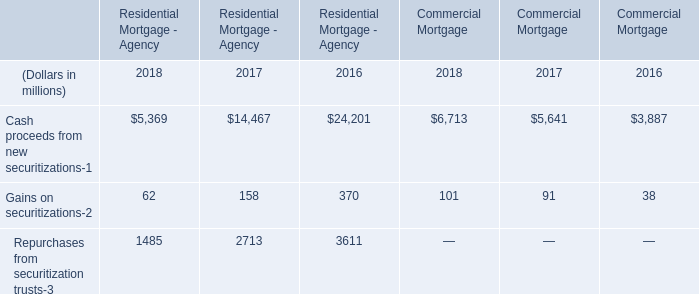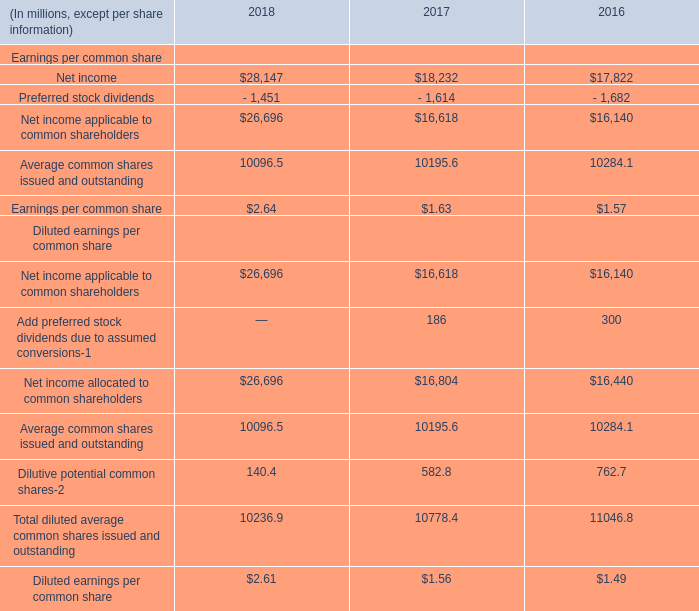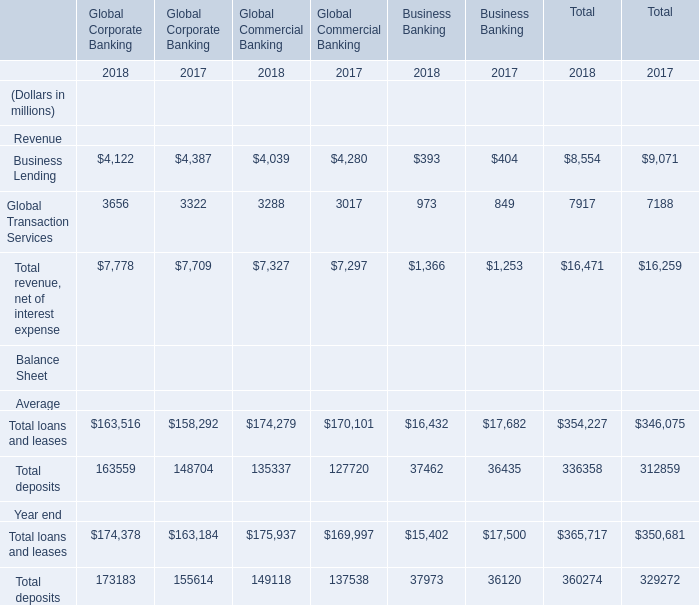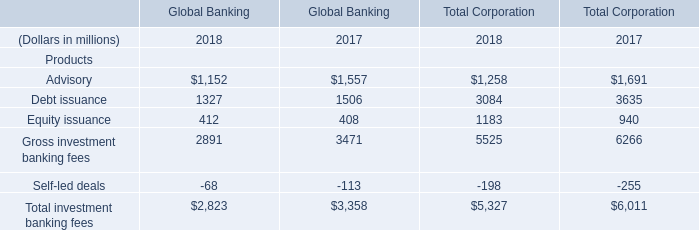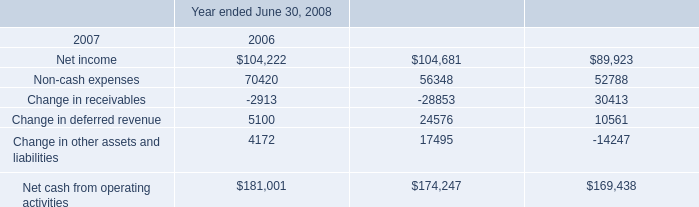what was the percentage change in the cash and cash equivalents at june 30 , 2008 from 2007 . 
Computations: ((65565 - 88617) / 88617)
Answer: -0.26013. 